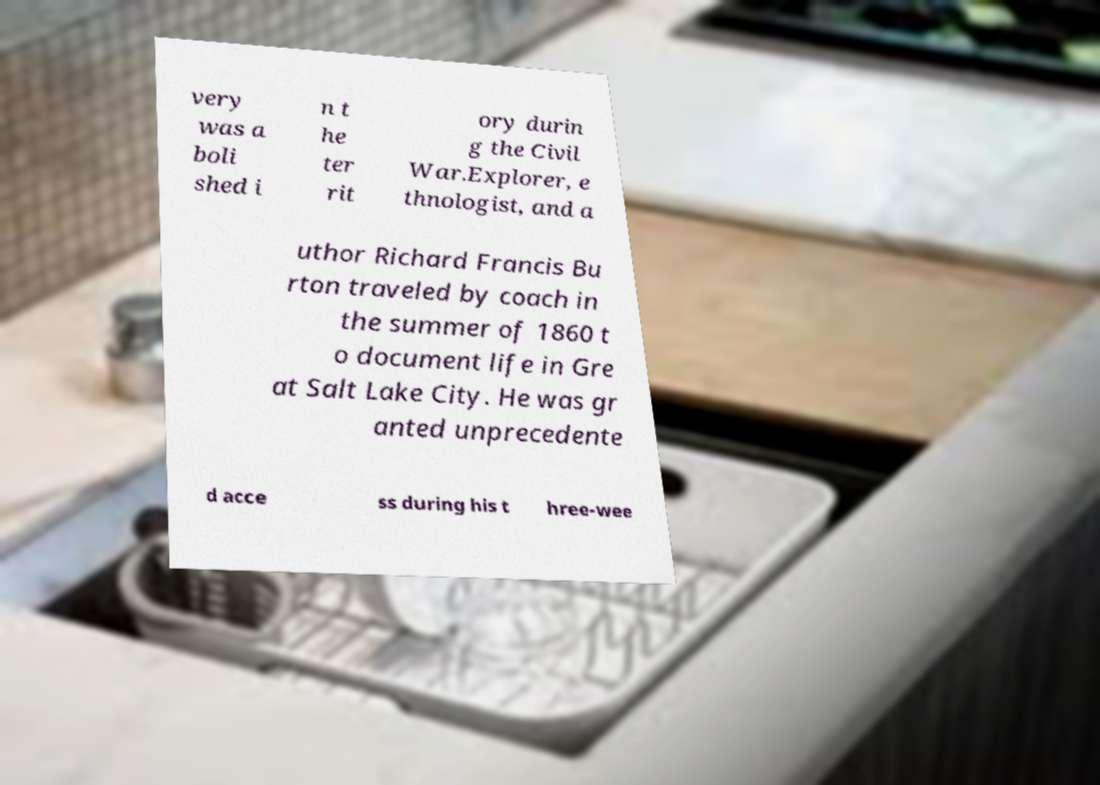There's text embedded in this image that I need extracted. Can you transcribe it verbatim? very was a boli shed i n t he ter rit ory durin g the Civil War.Explorer, e thnologist, and a uthor Richard Francis Bu rton traveled by coach in the summer of 1860 t o document life in Gre at Salt Lake City. He was gr anted unprecedente d acce ss during his t hree-wee 